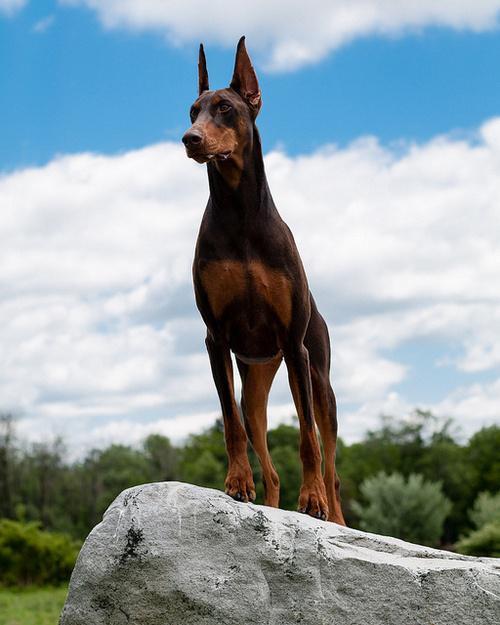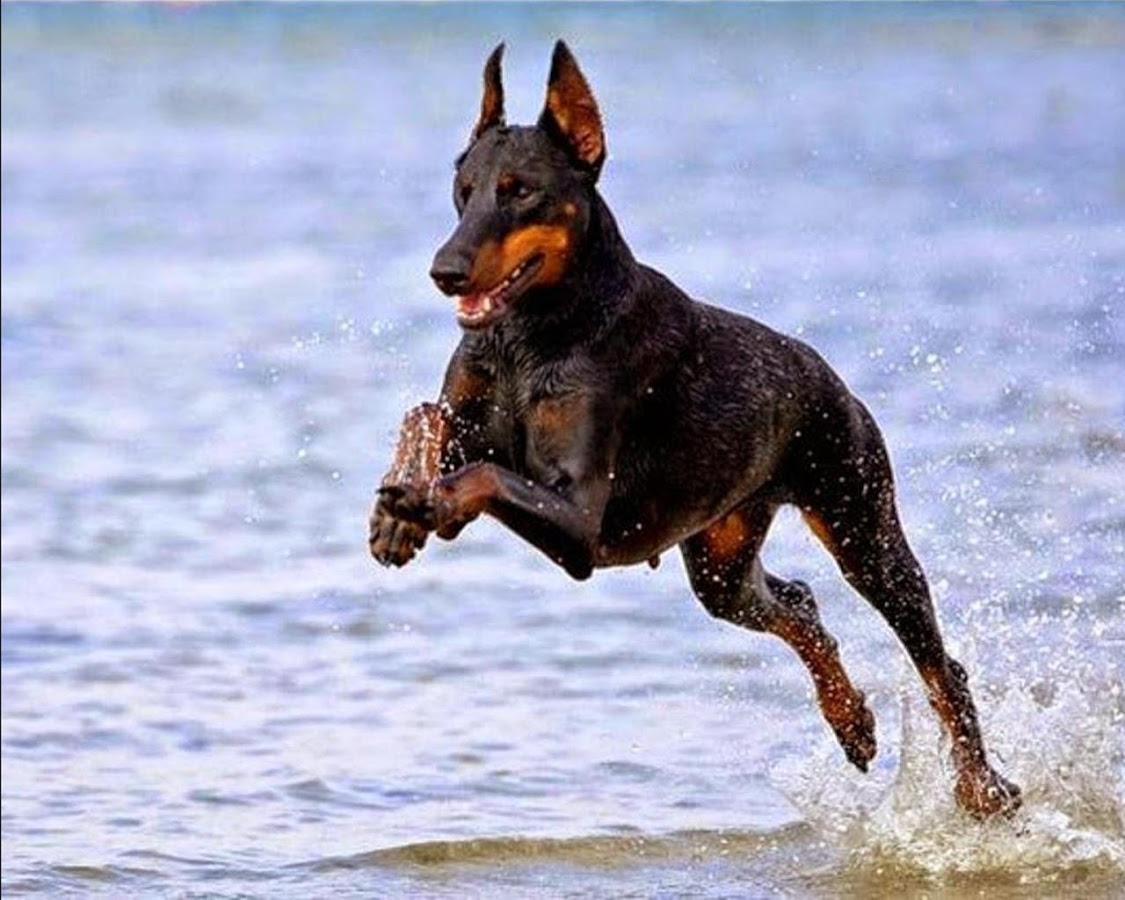The first image is the image on the left, the second image is the image on the right. For the images shown, is this caption "The right image includes two erect-eared dobermans reclining on fallen leaves, with their bodies turned forward." true? Answer yes or no. No. The first image is the image on the left, the second image is the image on the right. Evaluate the accuracy of this statement regarding the images: "The right image contains no more than one dog.". Is it true? Answer yes or no. Yes. 